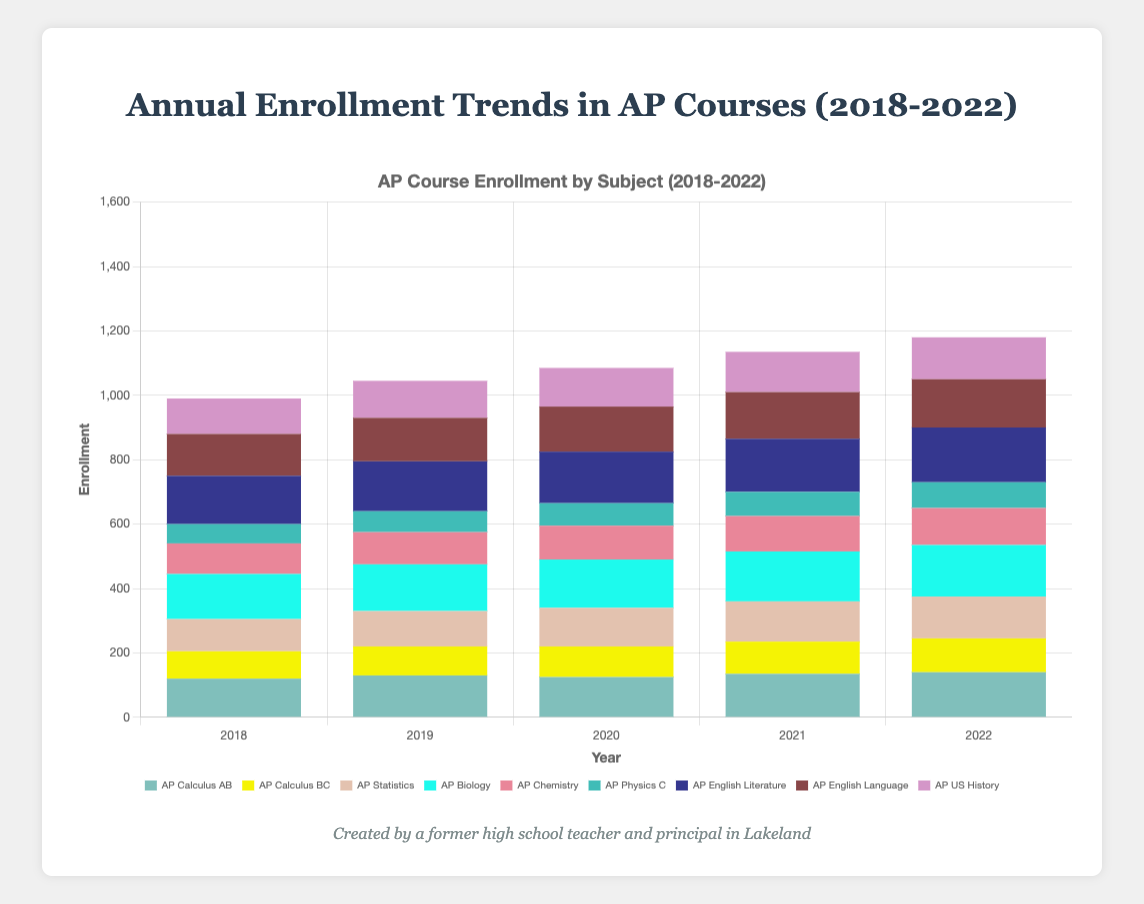What's the total enrollment for AP Science courses in 2022? Sum the enrollments for AP Biology (160), AP Chemistry (115), and AP Physics C (80) for the year 2022. Total enrollment = 160 + 115 + 80 = 355
Answer: 355 Which AP course had the highest enrollment in 2020? Compare the enrollment numbers for all AP courses in 2020. AP English Literature had the highest enrollment with 160 students.
Answer: AP English Literature How did the enrollment for AP Calculus AB change from 2018 to 2022? Subtract the enrollment number of AP Calculus AB in 2018 (120) from that in 2022 (140). The change is 140 - 120 = 20, an increase of 20 students.
Answer: Increased by 20 Which subject saw the highest overall increase in enrollment from 2018 to 2022? Calculate the total enrollment for each subject in 2018 and 2022 and find the difference. Mathematics: 305 to 375 (+70), Science: 295 to 355 (+60), Humanities: 390 to 450 (+60). Mathematics saw the highest increase.
Answer: Mathematics What’s the average enrollment for AP US History between 2018 and 2022? (110 (2018) + 115 (2019) + 120 (2020) + 125 (2021) + 130 (2022)) / 5 = 120
Answer: 120 Visualize the heights of the bars for AP Biology enrollment from 2018 to 2022. How does the trend look? Notice the increasing heights of the bars for AP Biology each year from 140 (2018), 145, 150, 155, to 160 (2022). The trend shows a steady increase.
Answer: Steady increase Compare the enrollment for AP Chemistry and AP Physics C in 2021. Which course had more students? Compare the numbers: AP Chemistry (110) and AP Physics C (75) for 2021. AP Chemistry had more students.
Answer: AP Chemistry Is there an increasing trend in enrollment for AP English Language from 2018 to 2022? Observe the enrollment numbers for AP English Language from 2018 (130), 135, 140, 145, to 150 in 2022. There is a consistent increase each year.
Answer: Yes What’s the total enrollment in Humanities subjects for each year? Sum the enrollment numbers for AP English Literature, AP English Language, and AP US History for each year:
2018: 150 + 130 + 110 = 390
2019: 155 + 135 + 115 = 405
2020: 160 + 140 + 120 = 420
2021: 165 + 145 + 125 = 435
2022: 170 + 150 + 130 = 450
Answer: 390, 405, 420, 435, 450 